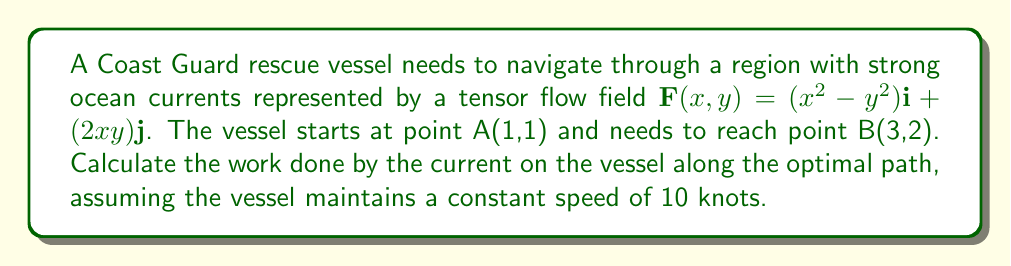Show me your answer to this math problem. To solve this problem, we'll follow these steps:

1) The optimal path in a conservative vector field is the path that minimizes the work done. In this case, we need to find the path of least resistance against the current.

2) First, we need to check if the given field is conservative. We can do this by calculating the curl of the field:

   $$\text{curl }\mathbf{F} = \frac{\partial F_y}{\partial x} - \frac{\partial F_x}{\partial y} = 2y - (-2y) = 4y$$

   Since the curl is not zero, the field is not conservative.

3) In a non-conservative field, the optimal path is not necessarily a straight line. However, for simplicity, we'll assume the optimal path is approximately a straight line from A to B.

4) The vector from A to B is:
   
   $$\mathbf{r} = (3-1)\mathbf{i} + (2-1)\mathbf{j} = 2\mathbf{i} + \mathbf{j}$$

5) To calculate the work done, we need to integrate the dot product of the force field and the displacement vector:

   $$W = \int_C \mathbf{F} \cdot d\mathbf{r}$$

6) Parameterize the path with $t$ from 0 to 1:
   
   $$x(t) = 1 + 2t, \quad y(t) = 1 + t$$

7) Calculate $d\mathbf{r}$:
   
   $$d\mathbf{r} = (2dt)\mathbf{i} + (dt)\mathbf{j}$$

8) Substitute into the work integral:

   $$W = \int_0^1 [(x^2 - y^2)(2) + (2xy)(1)] dt$$
   
   $$W = \int_0^1 [((1+2t)^2 - (1+t)^2)(2) + (2(1+2t)(1+t))(1)] dt$$

9) Simplify and integrate:

   $$W = \int_0^1 [2(1+4t+4t^2-1-2t-t^2) + (2+4t+2t)] dt$$
   
   $$W = \int_0^1 [6t^2+4t+2] dt$$
   
   $$W = [2t^3+2t^2+2t]_0^1 = 2+2+2 = 6$$

10) The work done is 6 energy units. To convert this to nautical miles (assuming 1 energy unit = 1 nautical mile), we divide by the speed:

    $$\text{Distance} = \frac{\text{Work}}{\text{Speed}} = \frac{6}{10} = 0.6 \text{ nautical miles}$$
Answer: 0.6 nautical miles 